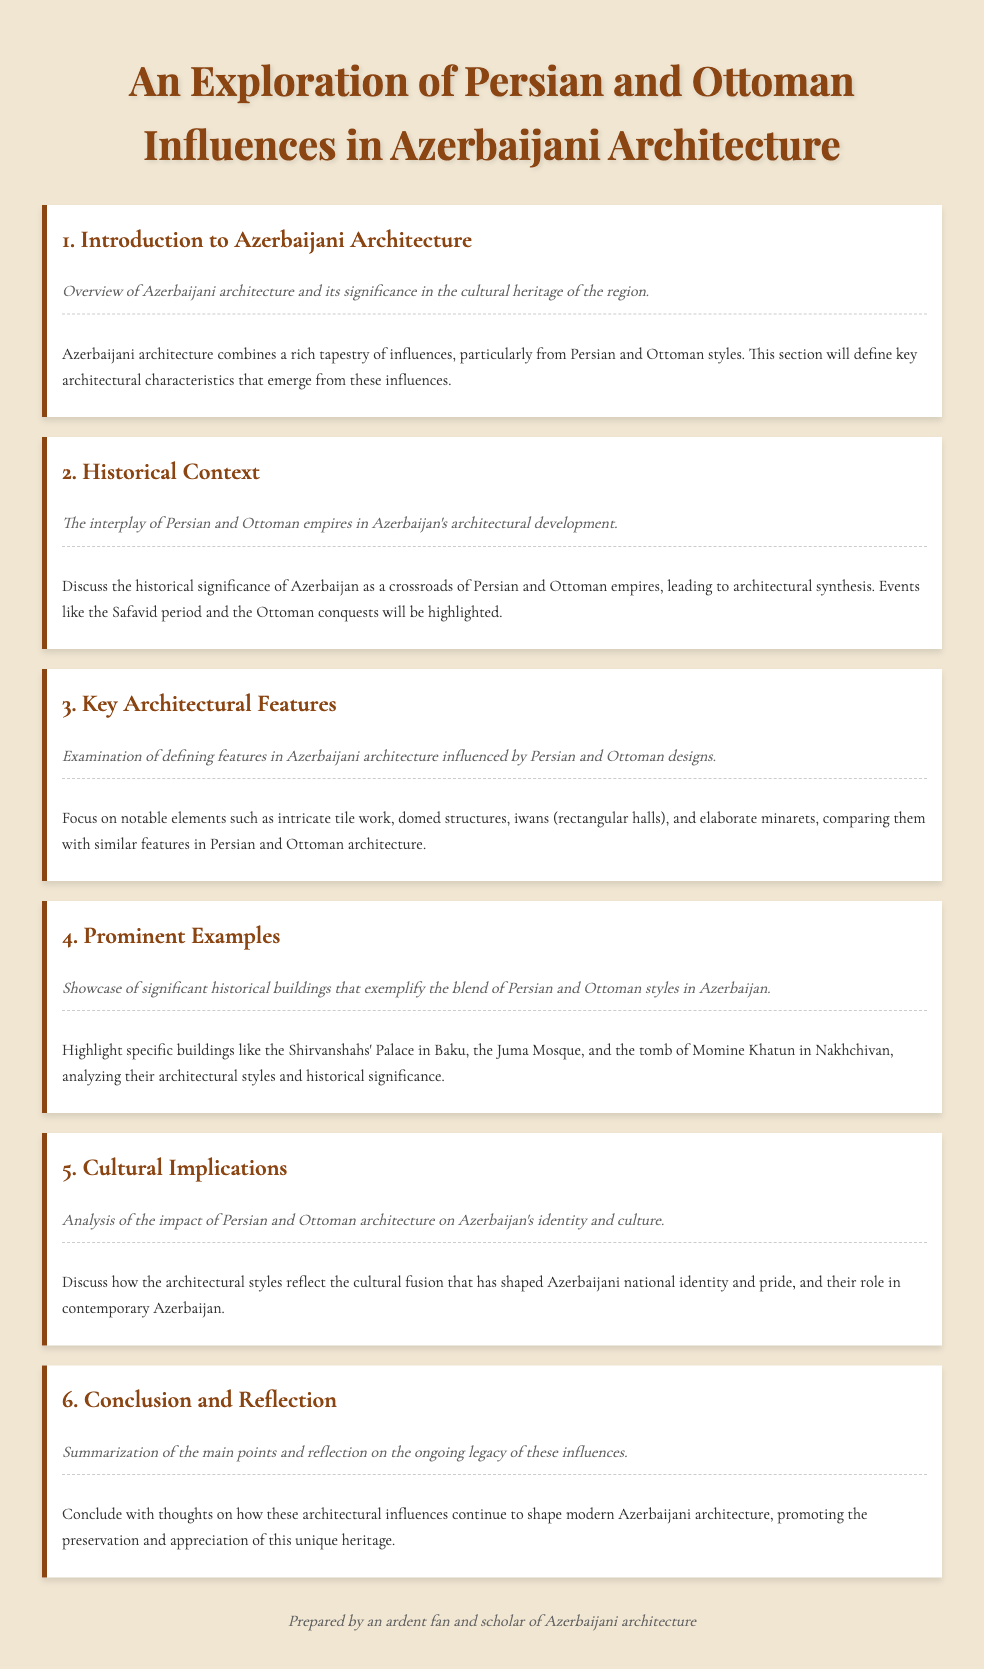What is the title of the document? The title of the document is presented at the top of the rendered page, summarizing its main theme.
Answer: An Exploration of Persian and Ottoman Influences in Azerbaijani Architecture How many main sections are in the agenda? The number of main sections is indicated by the numbered agenda items listed in the document.
Answer: Six What historical period is highlighted in the second section? The second section emphasizes a specific historical period that contributes to the architectural development in Azerbaijan.
Answer: Safavid period Which building is mentioned as an example in the fourth section? The fourth section highlights specific historical buildings as examples of the architectural blend in Azerbaijan.
Answer: Shirvanshahs' Palace What architectural feature is significant in Azerbaijani architecture according to the third section? The third section discusses architectural features that are defining elements in Azerbaijani architecture influenced by Persian and Ottoman styles.
Answer: Intricate tile work What is the main cultural theme discussed in section five? The fifth section analyzes the effects of architectural styles on a particular aspect of Azerbaijani culture and identity.
Answer: National identity What type of architecture does the document primarily focus on? The document focuses on a specific architectural style influenced by two significant historical empires in the region.
Answer: Persian and Ottoman architecture What does the conclusion of the document reflect on? The conclusion summarizes the document's discussions and reflects on a specific aspect of the architectural styles in Azerbaijani architecture.
Answer: Ongoing legacy 